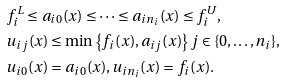<formula> <loc_0><loc_0><loc_500><loc_500>& f ^ { L } _ { i } \leq a _ { i 0 } ( x ) \leq \dots \leq a _ { i n _ { i } } ( x ) \leq f ^ { U } _ { i } , \\ & u _ { i j } ( x ) \leq \min \left \{ f _ { i } ( x ) , a _ { i j } ( x ) \right \} j \in \{ 0 , \dots , n _ { i } \} , \\ & u _ { i 0 } ( x ) = a _ { i 0 } ( x ) , u _ { i n _ { i } } ( x ) = f _ { i } ( x ) .</formula> 